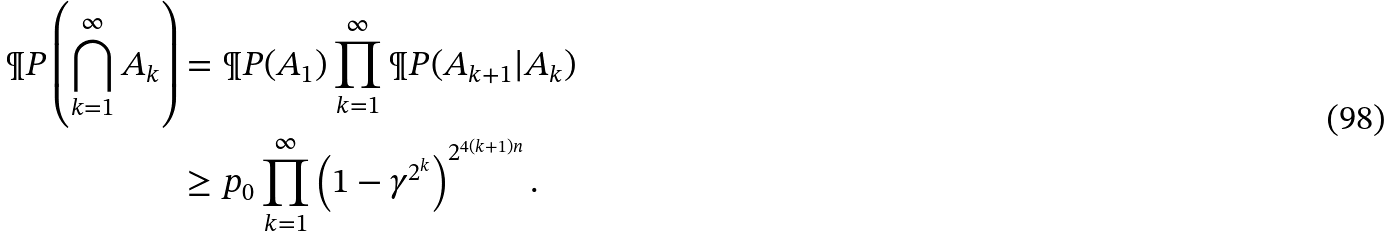Convert formula to latex. <formula><loc_0><loc_0><loc_500><loc_500>\P P \left ( \bigcap _ { k = 1 } ^ { \infty } A _ { k } \right ) & = \P P ( A _ { 1 } ) \prod _ { k = 1 } ^ { \infty } \P P ( A _ { k + 1 } | A _ { k } ) \\ & \geq p _ { 0 } \prod _ { k = 1 } ^ { \infty } \left ( 1 - \gamma ^ { 2 ^ { k } } \right ) ^ { 2 ^ { 4 ( k + 1 ) n } } .</formula> 